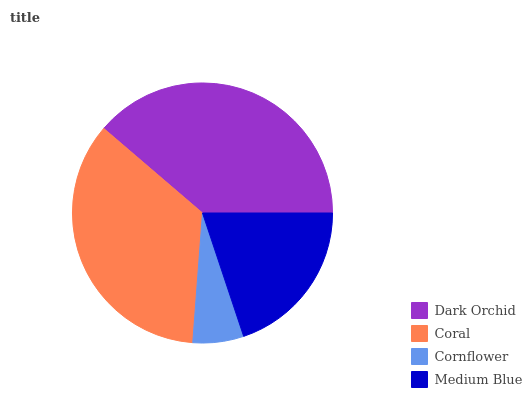Is Cornflower the minimum?
Answer yes or no. Yes. Is Dark Orchid the maximum?
Answer yes or no. Yes. Is Coral the minimum?
Answer yes or no. No. Is Coral the maximum?
Answer yes or no. No. Is Dark Orchid greater than Coral?
Answer yes or no. Yes. Is Coral less than Dark Orchid?
Answer yes or no. Yes. Is Coral greater than Dark Orchid?
Answer yes or no. No. Is Dark Orchid less than Coral?
Answer yes or no. No. Is Coral the high median?
Answer yes or no. Yes. Is Medium Blue the low median?
Answer yes or no. Yes. Is Cornflower the high median?
Answer yes or no. No. Is Coral the low median?
Answer yes or no. No. 